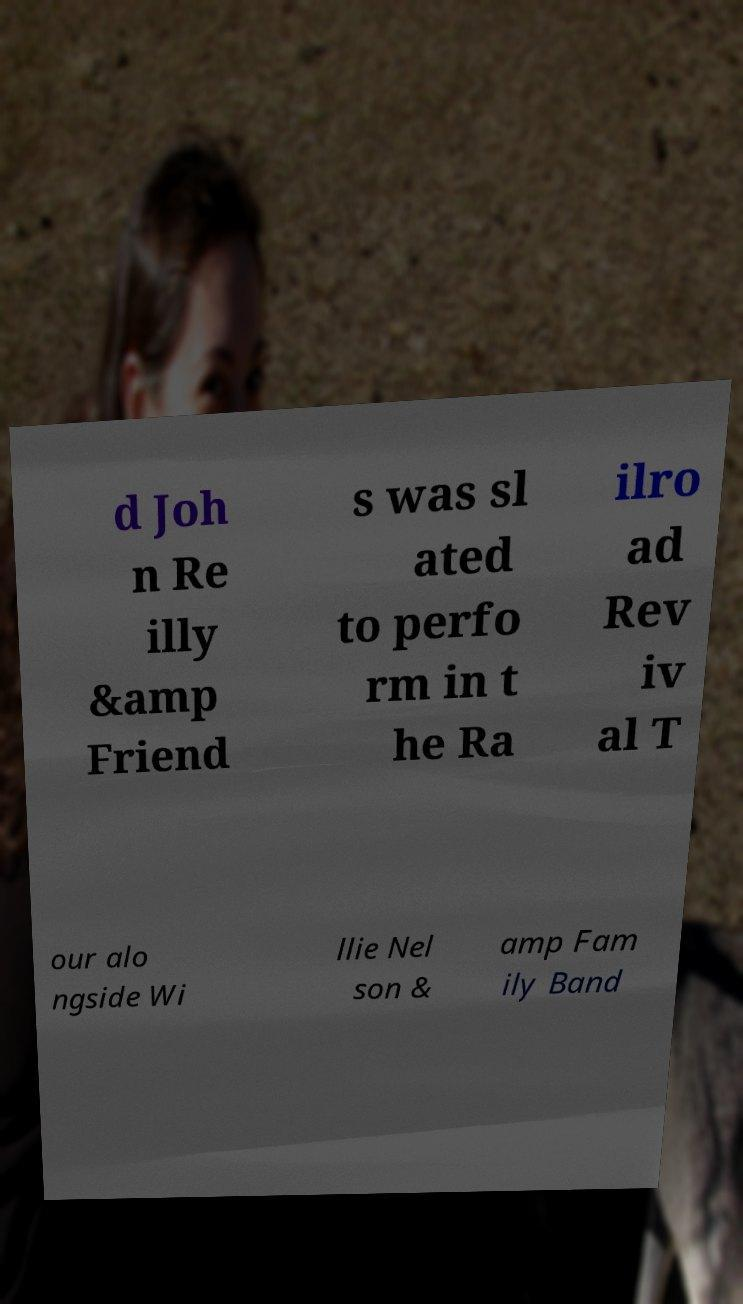Please identify and transcribe the text found in this image. d Joh n Re illy &amp Friend s was sl ated to perfo rm in t he Ra ilro ad Rev iv al T our alo ngside Wi llie Nel son & amp Fam ily Band 